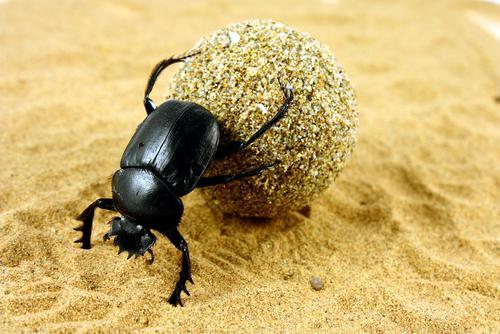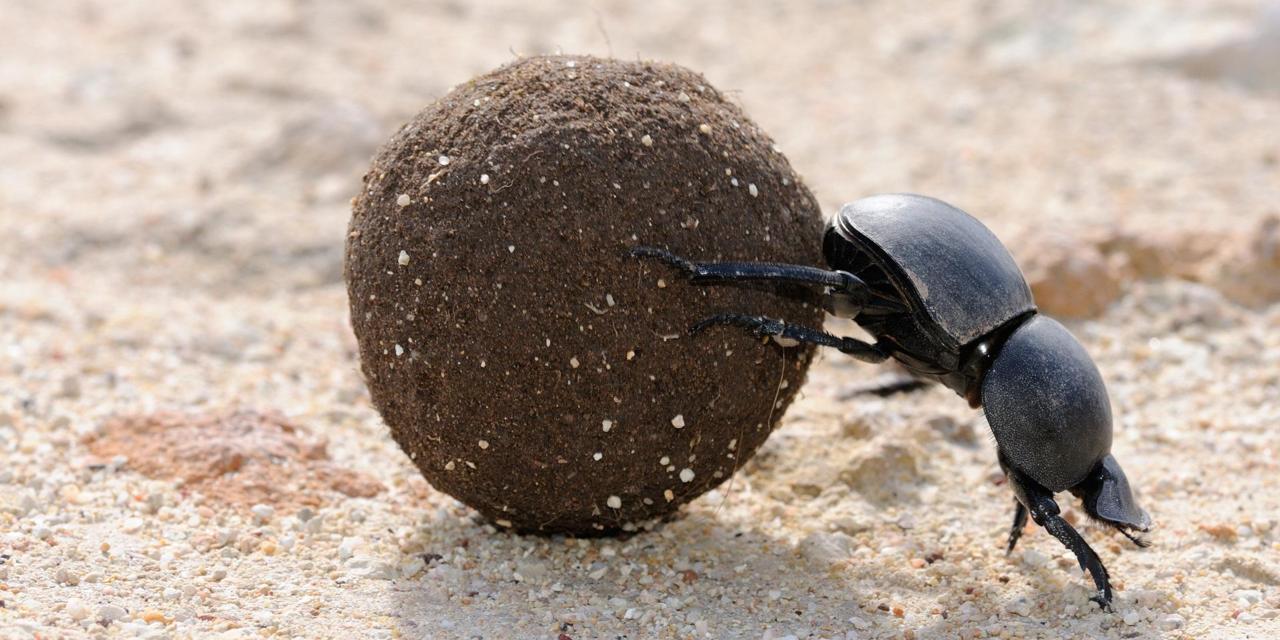The first image is the image on the left, the second image is the image on the right. Evaluate the accuracy of this statement regarding the images: "At least one beetle is in contact with a round, not oblong, ball.". Is it true? Answer yes or no. Yes. 